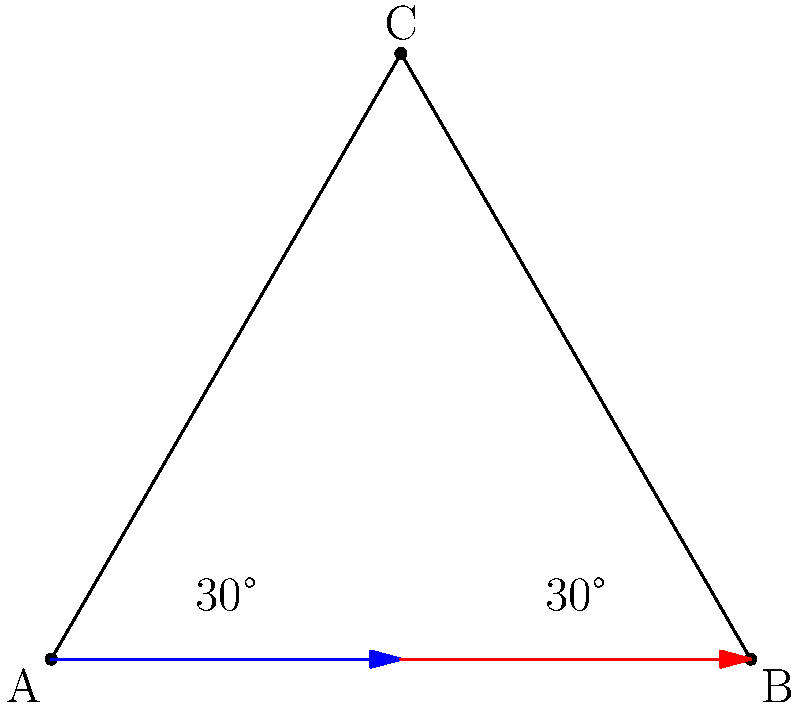In boxing, head movement is crucial for defensive techniques. Consider the triangle ABC representing a boxer's head position, where the base AB represents the neutral stance. If the boxer moves their head to position C, creating two 30° angles at the base, what is the total angle of head movement from A to B through C, and how might this movement be advantageous in a boxing match? Let's approach this step-by-step:

1) First, we need to identify the triangle. We have an isosceles triangle ABC, where AC = BC.

2) We're given that the angles at A and B are both 30°. In an isosceles triangle, the angles opposite the equal sides are equal. So, angle CAB = angle CBA = 30°.

3) To find the angle at C, we can use the fact that the sum of angles in a triangle is 180°:
   $$180° = 30° + 30° + \angle ACB$$
   $$\angle ACB = 180° - 60° = 120°$$

4) The total angle of head movement from A to B through C is this angle at C, which is 120°.

5) This movement can be advantageous in boxing because:
   a) It allows the boxer to evade punches coming from either side.
   b) The wide angle gives a good field of vision to spot incoming attacks.
   c) It puts the boxer in a position to counter-attack from either side.
   d) The symmetrical nature of the movement (30° to each side) allows for quick, balanced recovery to the neutral stance.

For an aspiring writer, understanding this geometric perspective on boxing techniques can add depth and technical accuracy to fight scene descriptions, enhancing the realism of the narrative.
Answer: 120°; provides evasion, vision, counter-attack opportunities, and balanced recovery. 